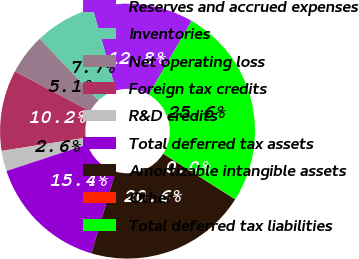<chart> <loc_0><loc_0><loc_500><loc_500><pie_chart><fcel>Reserves and accrued expenses<fcel>Inventories<fcel>Net operating loss<fcel>Foreign tax credits<fcel>R&D credits<fcel>Total deferred tax assets<fcel>Amortizable intangible assets<fcel>Other<fcel>Total deferred tax liabilities<nl><fcel>12.8%<fcel>7.69%<fcel>5.14%<fcel>10.25%<fcel>2.58%<fcel>15.36%<fcel>20.58%<fcel>0.02%<fcel>25.58%<nl></chart> 